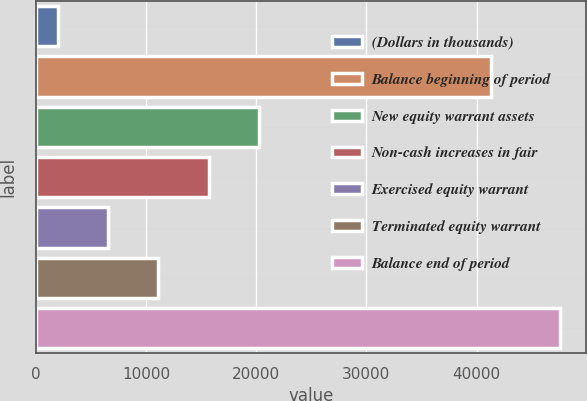Convert chart to OTSL. <chart><loc_0><loc_0><loc_500><loc_500><bar_chart><fcel>(Dollars in thousands)<fcel>Balance beginning of period<fcel>New equity warrant assets<fcel>Non-cash increases in fair<fcel>Exercised equity warrant<fcel>Terminated equity warrant<fcel>Balance end of period<nl><fcel>2010<fcel>41292<fcel>20232<fcel>15676.5<fcel>6565.5<fcel>11121<fcel>47565<nl></chart> 